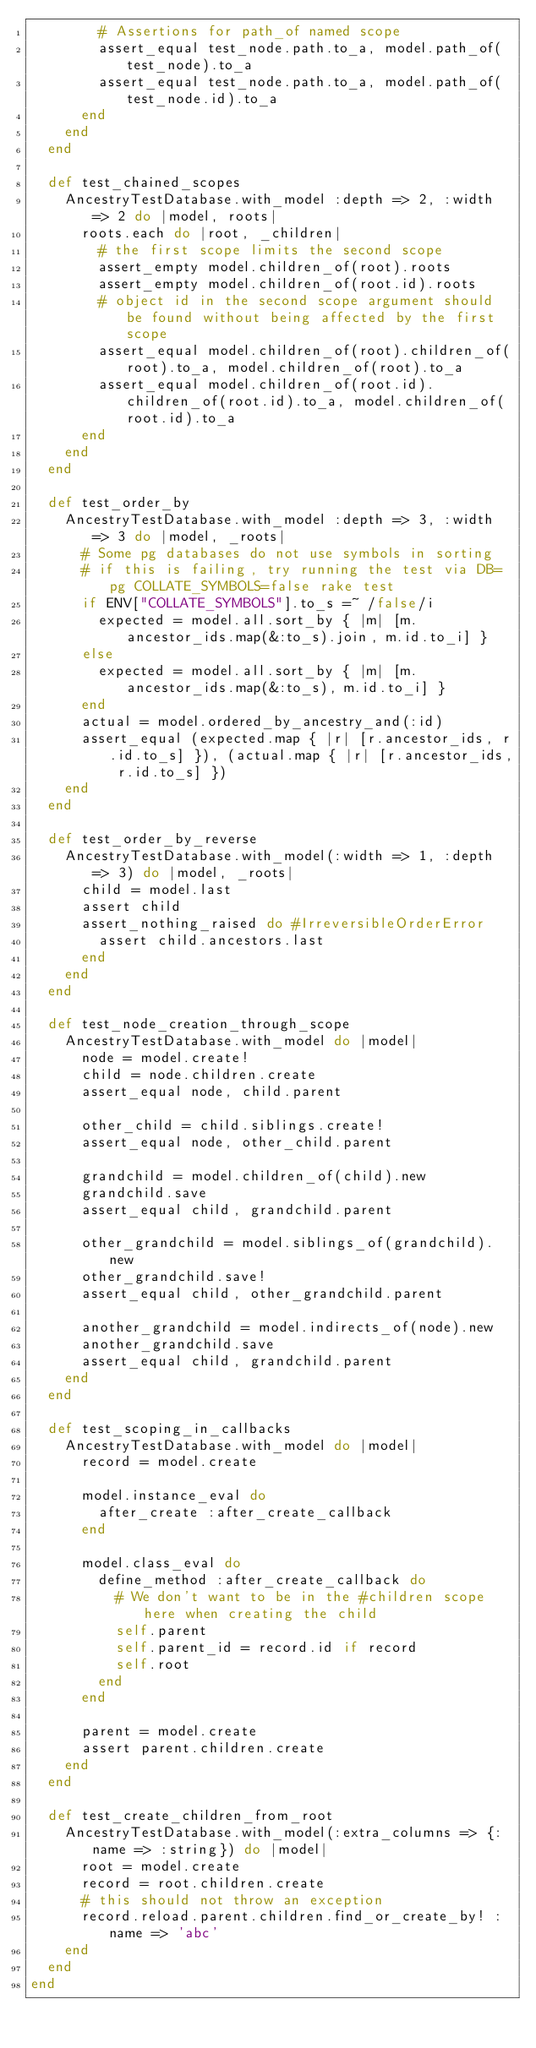<code> <loc_0><loc_0><loc_500><loc_500><_Ruby_>        # Assertions for path_of named scope
        assert_equal test_node.path.to_a, model.path_of(test_node).to_a
        assert_equal test_node.path.to_a, model.path_of(test_node.id).to_a
      end
    end
  end

  def test_chained_scopes
    AncestryTestDatabase.with_model :depth => 2, :width => 2 do |model, roots|
      roots.each do |root, _children|
        # the first scope limits the second scope
        assert_empty model.children_of(root).roots
        assert_empty model.children_of(root.id).roots
        # object id in the second scope argument should be found without being affected by the first scope
        assert_equal model.children_of(root).children_of(root).to_a, model.children_of(root).to_a
        assert_equal model.children_of(root.id).children_of(root.id).to_a, model.children_of(root.id).to_a
      end
    end
  end

  def test_order_by
    AncestryTestDatabase.with_model :depth => 3, :width => 3 do |model, _roots|
      # Some pg databases do not use symbols in sorting
      # if this is failing, try running the test via DB=pg COLLATE_SYMBOLS=false rake test
      if ENV["COLLATE_SYMBOLS"].to_s =~ /false/i
        expected = model.all.sort_by { |m| [m.ancestor_ids.map(&:to_s).join, m.id.to_i] }
      else
        expected = model.all.sort_by { |m| [m.ancestor_ids.map(&:to_s), m.id.to_i] }
      end
      actual = model.ordered_by_ancestry_and(:id)
      assert_equal (expected.map { |r| [r.ancestor_ids, r.id.to_s] }), (actual.map { |r| [r.ancestor_ids, r.id.to_s] })
    end
  end

  def test_order_by_reverse
    AncestryTestDatabase.with_model(:width => 1, :depth => 3) do |model, _roots|
      child = model.last
      assert child
      assert_nothing_raised do #IrreversibleOrderError
        assert child.ancestors.last
      end
    end
  end

  def test_node_creation_through_scope
    AncestryTestDatabase.with_model do |model|
      node = model.create!
      child = node.children.create
      assert_equal node, child.parent

      other_child = child.siblings.create!
      assert_equal node, other_child.parent

      grandchild = model.children_of(child).new
      grandchild.save
      assert_equal child, grandchild.parent

      other_grandchild = model.siblings_of(grandchild).new
      other_grandchild.save!
      assert_equal child, other_grandchild.parent

      another_grandchild = model.indirects_of(node).new
      another_grandchild.save
      assert_equal child, grandchild.parent
    end
  end

  def test_scoping_in_callbacks
    AncestryTestDatabase.with_model do |model|
      record = model.create

      model.instance_eval do
        after_create :after_create_callback
      end

      model.class_eval do
        define_method :after_create_callback do
          # We don't want to be in the #children scope here when creating the child
          self.parent
          self.parent_id = record.id if record
          self.root
        end
      end

      parent = model.create
      assert parent.children.create
    end
  end

  def test_create_children_from_root
    AncestryTestDatabase.with_model(:extra_columns => {:name => :string}) do |model|
      root = model.create
      record = root.children.create
      # this should not throw an exception
      record.reload.parent.children.find_or_create_by! :name => 'abc'
    end
  end
end
</code> 